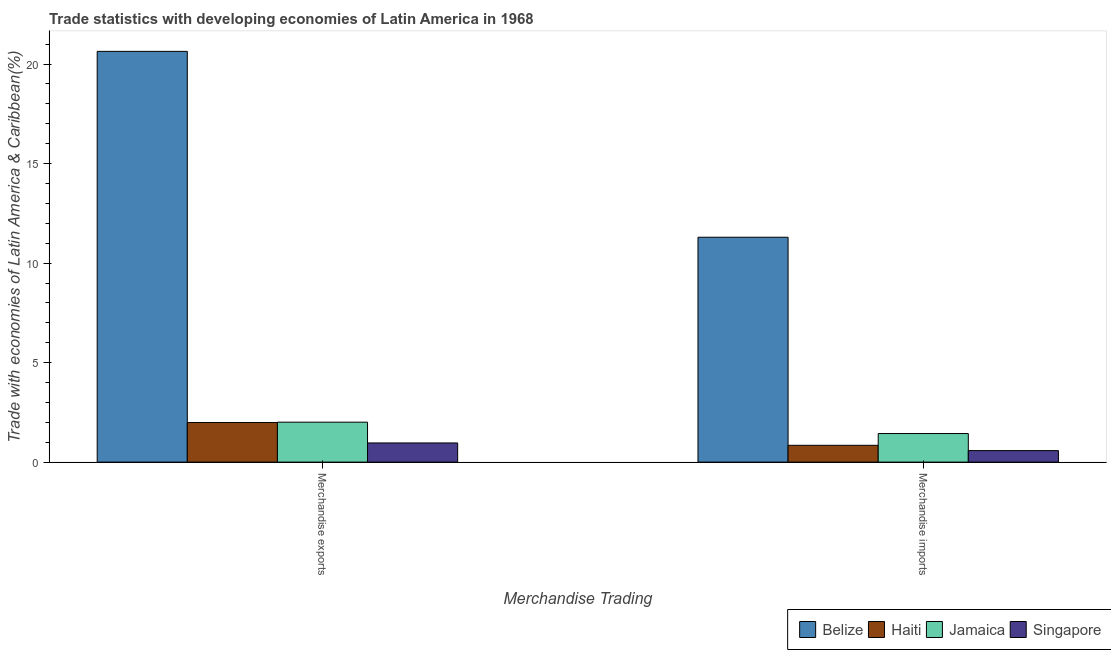How many different coloured bars are there?
Keep it short and to the point. 4. Are the number of bars per tick equal to the number of legend labels?
Keep it short and to the point. Yes. Are the number of bars on each tick of the X-axis equal?
Offer a very short reply. Yes. What is the label of the 2nd group of bars from the left?
Keep it short and to the point. Merchandise imports. What is the merchandise exports in Jamaica?
Give a very brief answer. 2.01. Across all countries, what is the maximum merchandise imports?
Offer a very short reply. 11.3. Across all countries, what is the minimum merchandise exports?
Offer a very short reply. 0.96. In which country was the merchandise exports maximum?
Make the answer very short. Belize. In which country was the merchandise exports minimum?
Your answer should be very brief. Singapore. What is the total merchandise exports in the graph?
Keep it short and to the point. 25.6. What is the difference between the merchandise exports in Haiti and that in Singapore?
Ensure brevity in your answer.  1.03. What is the difference between the merchandise exports in Singapore and the merchandise imports in Belize?
Offer a terse response. -10.34. What is the average merchandise imports per country?
Offer a very short reply. 3.54. What is the difference between the merchandise exports and merchandise imports in Singapore?
Provide a succinct answer. 0.39. What is the ratio of the merchandise exports in Belize to that in Jamaica?
Keep it short and to the point. 10.28. Is the merchandise imports in Haiti less than that in Singapore?
Offer a very short reply. No. What does the 3rd bar from the left in Merchandise imports represents?
Provide a short and direct response. Jamaica. What does the 1st bar from the right in Merchandise exports represents?
Give a very brief answer. Singapore. How many countries are there in the graph?
Keep it short and to the point. 4. What is the difference between two consecutive major ticks on the Y-axis?
Your answer should be compact. 5. Are the values on the major ticks of Y-axis written in scientific E-notation?
Your answer should be compact. No. Does the graph contain any zero values?
Provide a succinct answer. No. Does the graph contain grids?
Your response must be concise. No. How many legend labels are there?
Keep it short and to the point. 4. How are the legend labels stacked?
Offer a terse response. Horizontal. What is the title of the graph?
Provide a short and direct response. Trade statistics with developing economies of Latin America in 1968. What is the label or title of the X-axis?
Offer a very short reply. Merchandise Trading. What is the label or title of the Y-axis?
Your answer should be compact. Trade with economies of Latin America & Caribbean(%). What is the Trade with economies of Latin America & Caribbean(%) in Belize in Merchandise exports?
Give a very brief answer. 20.64. What is the Trade with economies of Latin America & Caribbean(%) of Haiti in Merchandise exports?
Ensure brevity in your answer.  1.99. What is the Trade with economies of Latin America & Caribbean(%) of Jamaica in Merchandise exports?
Your answer should be very brief. 2.01. What is the Trade with economies of Latin America & Caribbean(%) of Singapore in Merchandise exports?
Give a very brief answer. 0.96. What is the Trade with economies of Latin America & Caribbean(%) in Belize in Merchandise imports?
Give a very brief answer. 11.3. What is the Trade with economies of Latin America & Caribbean(%) of Haiti in Merchandise imports?
Give a very brief answer. 0.85. What is the Trade with economies of Latin America & Caribbean(%) of Jamaica in Merchandise imports?
Ensure brevity in your answer.  1.44. What is the Trade with economies of Latin America & Caribbean(%) in Singapore in Merchandise imports?
Offer a terse response. 0.58. Across all Merchandise Trading, what is the maximum Trade with economies of Latin America & Caribbean(%) in Belize?
Your response must be concise. 20.64. Across all Merchandise Trading, what is the maximum Trade with economies of Latin America & Caribbean(%) of Haiti?
Make the answer very short. 1.99. Across all Merchandise Trading, what is the maximum Trade with economies of Latin America & Caribbean(%) of Jamaica?
Your answer should be compact. 2.01. Across all Merchandise Trading, what is the maximum Trade with economies of Latin America & Caribbean(%) of Singapore?
Your response must be concise. 0.96. Across all Merchandise Trading, what is the minimum Trade with economies of Latin America & Caribbean(%) in Belize?
Provide a short and direct response. 11.3. Across all Merchandise Trading, what is the minimum Trade with economies of Latin America & Caribbean(%) in Haiti?
Make the answer very short. 0.85. Across all Merchandise Trading, what is the minimum Trade with economies of Latin America & Caribbean(%) of Jamaica?
Provide a short and direct response. 1.44. Across all Merchandise Trading, what is the minimum Trade with economies of Latin America & Caribbean(%) in Singapore?
Offer a very short reply. 0.58. What is the total Trade with economies of Latin America & Caribbean(%) of Belize in the graph?
Offer a terse response. 31.94. What is the total Trade with economies of Latin America & Caribbean(%) in Haiti in the graph?
Your response must be concise. 2.83. What is the total Trade with economies of Latin America & Caribbean(%) of Jamaica in the graph?
Your response must be concise. 3.44. What is the total Trade with economies of Latin America & Caribbean(%) of Singapore in the graph?
Your response must be concise. 1.54. What is the difference between the Trade with economies of Latin America & Caribbean(%) of Belize in Merchandise exports and that in Merchandise imports?
Offer a terse response. 9.34. What is the difference between the Trade with economies of Latin America & Caribbean(%) in Haiti in Merchandise exports and that in Merchandise imports?
Your response must be concise. 1.14. What is the difference between the Trade with economies of Latin America & Caribbean(%) of Jamaica in Merchandise exports and that in Merchandise imports?
Ensure brevity in your answer.  0.57. What is the difference between the Trade with economies of Latin America & Caribbean(%) in Singapore in Merchandise exports and that in Merchandise imports?
Give a very brief answer. 0.39. What is the difference between the Trade with economies of Latin America & Caribbean(%) in Belize in Merchandise exports and the Trade with economies of Latin America & Caribbean(%) in Haiti in Merchandise imports?
Make the answer very short. 19.79. What is the difference between the Trade with economies of Latin America & Caribbean(%) of Belize in Merchandise exports and the Trade with economies of Latin America & Caribbean(%) of Jamaica in Merchandise imports?
Provide a short and direct response. 19.2. What is the difference between the Trade with economies of Latin America & Caribbean(%) of Belize in Merchandise exports and the Trade with economies of Latin America & Caribbean(%) of Singapore in Merchandise imports?
Give a very brief answer. 20.06. What is the difference between the Trade with economies of Latin America & Caribbean(%) of Haiti in Merchandise exports and the Trade with economies of Latin America & Caribbean(%) of Jamaica in Merchandise imports?
Give a very brief answer. 0.55. What is the difference between the Trade with economies of Latin America & Caribbean(%) in Haiti in Merchandise exports and the Trade with economies of Latin America & Caribbean(%) in Singapore in Merchandise imports?
Your answer should be very brief. 1.41. What is the difference between the Trade with economies of Latin America & Caribbean(%) in Jamaica in Merchandise exports and the Trade with economies of Latin America & Caribbean(%) in Singapore in Merchandise imports?
Provide a succinct answer. 1.43. What is the average Trade with economies of Latin America & Caribbean(%) of Belize per Merchandise Trading?
Give a very brief answer. 15.97. What is the average Trade with economies of Latin America & Caribbean(%) of Haiti per Merchandise Trading?
Provide a short and direct response. 1.42. What is the average Trade with economies of Latin America & Caribbean(%) in Jamaica per Merchandise Trading?
Your response must be concise. 1.72. What is the average Trade with economies of Latin America & Caribbean(%) of Singapore per Merchandise Trading?
Offer a very short reply. 0.77. What is the difference between the Trade with economies of Latin America & Caribbean(%) in Belize and Trade with economies of Latin America & Caribbean(%) in Haiti in Merchandise exports?
Keep it short and to the point. 18.65. What is the difference between the Trade with economies of Latin America & Caribbean(%) in Belize and Trade with economies of Latin America & Caribbean(%) in Jamaica in Merchandise exports?
Provide a short and direct response. 18.63. What is the difference between the Trade with economies of Latin America & Caribbean(%) in Belize and Trade with economies of Latin America & Caribbean(%) in Singapore in Merchandise exports?
Provide a short and direct response. 19.68. What is the difference between the Trade with economies of Latin America & Caribbean(%) of Haiti and Trade with economies of Latin America & Caribbean(%) of Jamaica in Merchandise exports?
Offer a terse response. -0.02. What is the difference between the Trade with economies of Latin America & Caribbean(%) of Haiti and Trade with economies of Latin America & Caribbean(%) of Singapore in Merchandise exports?
Your answer should be very brief. 1.03. What is the difference between the Trade with economies of Latin America & Caribbean(%) in Jamaica and Trade with economies of Latin America & Caribbean(%) in Singapore in Merchandise exports?
Provide a short and direct response. 1.04. What is the difference between the Trade with economies of Latin America & Caribbean(%) of Belize and Trade with economies of Latin America & Caribbean(%) of Haiti in Merchandise imports?
Provide a succinct answer. 10.45. What is the difference between the Trade with economies of Latin America & Caribbean(%) of Belize and Trade with economies of Latin America & Caribbean(%) of Jamaica in Merchandise imports?
Your answer should be compact. 9.86. What is the difference between the Trade with economies of Latin America & Caribbean(%) of Belize and Trade with economies of Latin America & Caribbean(%) of Singapore in Merchandise imports?
Give a very brief answer. 10.72. What is the difference between the Trade with economies of Latin America & Caribbean(%) of Haiti and Trade with economies of Latin America & Caribbean(%) of Jamaica in Merchandise imports?
Your response must be concise. -0.59. What is the difference between the Trade with economies of Latin America & Caribbean(%) in Haiti and Trade with economies of Latin America & Caribbean(%) in Singapore in Merchandise imports?
Your answer should be very brief. 0.27. What is the difference between the Trade with economies of Latin America & Caribbean(%) in Jamaica and Trade with economies of Latin America & Caribbean(%) in Singapore in Merchandise imports?
Offer a terse response. 0.86. What is the ratio of the Trade with economies of Latin America & Caribbean(%) of Belize in Merchandise exports to that in Merchandise imports?
Keep it short and to the point. 1.83. What is the ratio of the Trade with economies of Latin America & Caribbean(%) of Haiti in Merchandise exports to that in Merchandise imports?
Your answer should be very brief. 2.35. What is the ratio of the Trade with economies of Latin America & Caribbean(%) of Jamaica in Merchandise exports to that in Merchandise imports?
Give a very brief answer. 1.4. What is the ratio of the Trade with economies of Latin America & Caribbean(%) in Singapore in Merchandise exports to that in Merchandise imports?
Offer a terse response. 1.67. What is the difference between the highest and the second highest Trade with economies of Latin America & Caribbean(%) of Belize?
Provide a short and direct response. 9.34. What is the difference between the highest and the second highest Trade with economies of Latin America & Caribbean(%) in Haiti?
Provide a succinct answer. 1.14. What is the difference between the highest and the second highest Trade with economies of Latin America & Caribbean(%) of Jamaica?
Keep it short and to the point. 0.57. What is the difference between the highest and the second highest Trade with economies of Latin America & Caribbean(%) of Singapore?
Your response must be concise. 0.39. What is the difference between the highest and the lowest Trade with economies of Latin America & Caribbean(%) of Belize?
Provide a short and direct response. 9.34. What is the difference between the highest and the lowest Trade with economies of Latin America & Caribbean(%) in Haiti?
Provide a short and direct response. 1.14. What is the difference between the highest and the lowest Trade with economies of Latin America & Caribbean(%) in Jamaica?
Give a very brief answer. 0.57. What is the difference between the highest and the lowest Trade with economies of Latin America & Caribbean(%) of Singapore?
Provide a short and direct response. 0.39. 